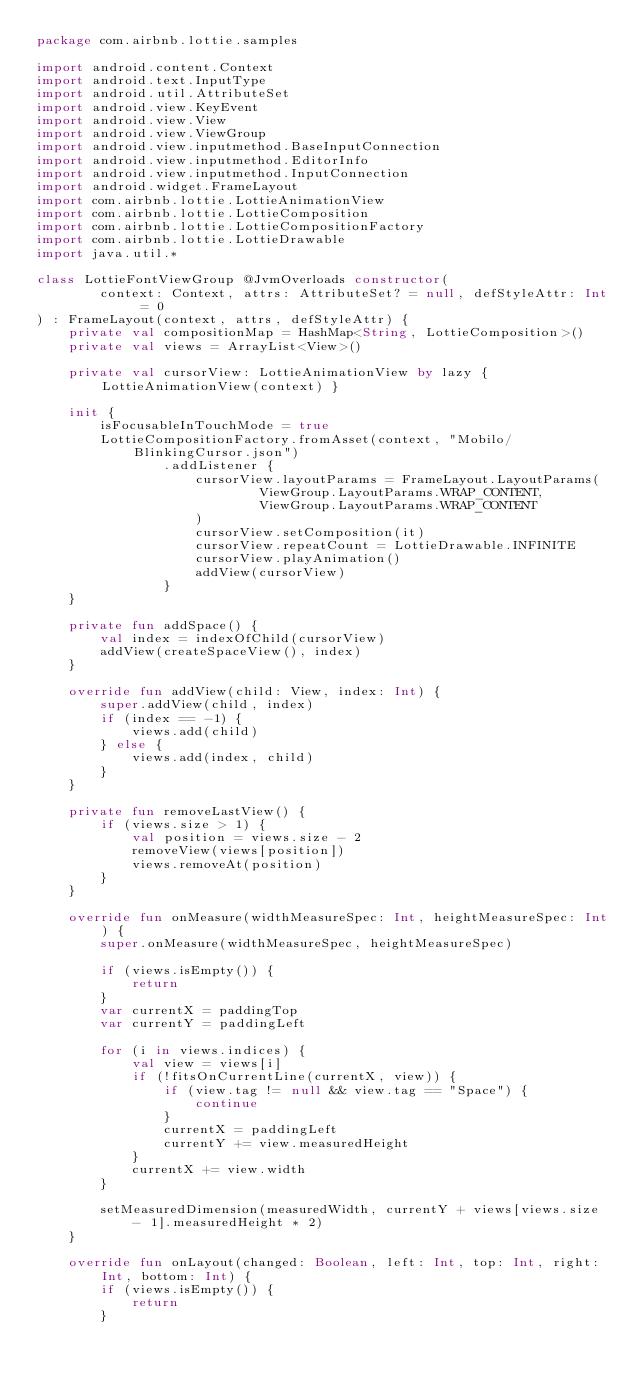<code> <loc_0><loc_0><loc_500><loc_500><_Kotlin_>package com.airbnb.lottie.samples

import android.content.Context
import android.text.InputType
import android.util.AttributeSet
import android.view.KeyEvent
import android.view.View
import android.view.ViewGroup
import android.view.inputmethod.BaseInputConnection
import android.view.inputmethod.EditorInfo
import android.view.inputmethod.InputConnection
import android.widget.FrameLayout
import com.airbnb.lottie.LottieAnimationView
import com.airbnb.lottie.LottieComposition
import com.airbnb.lottie.LottieCompositionFactory
import com.airbnb.lottie.LottieDrawable
import java.util.*

class LottieFontViewGroup @JvmOverloads constructor(
        context: Context, attrs: AttributeSet? = null, defStyleAttr: Int = 0
) : FrameLayout(context, attrs, defStyleAttr) {
    private val compositionMap = HashMap<String, LottieComposition>()
    private val views = ArrayList<View>()

    private val cursorView: LottieAnimationView by lazy { LottieAnimationView(context) }

    init {
        isFocusableInTouchMode = true
        LottieCompositionFactory.fromAsset(context, "Mobilo/BlinkingCursor.json")
                .addListener {
                    cursorView.layoutParams = FrameLayout.LayoutParams(
                            ViewGroup.LayoutParams.WRAP_CONTENT,
                            ViewGroup.LayoutParams.WRAP_CONTENT
                    )
                    cursorView.setComposition(it)
                    cursorView.repeatCount = LottieDrawable.INFINITE
                    cursorView.playAnimation()
                    addView(cursorView)
                }
    }

    private fun addSpace() {
        val index = indexOfChild(cursorView)
        addView(createSpaceView(), index)
    }

    override fun addView(child: View, index: Int) {
        super.addView(child, index)
        if (index == -1) {
            views.add(child)
        } else {
            views.add(index, child)
        }
    }

    private fun removeLastView() {
        if (views.size > 1) {
            val position = views.size - 2
            removeView(views[position])
            views.removeAt(position)
        }
    }

    override fun onMeasure(widthMeasureSpec: Int, heightMeasureSpec: Int) {
        super.onMeasure(widthMeasureSpec, heightMeasureSpec)

        if (views.isEmpty()) {
            return
        }
        var currentX = paddingTop
        var currentY = paddingLeft

        for (i in views.indices) {
            val view = views[i]
            if (!fitsOnCurrentLine(currentX, view)) {
                if (view.tag != null && view.tag == "Space") {
                    continue
                }
                currentX = paddingLeft
                currentY += view.measuredHeight
            }
            currentX += view.width
        }

        setMeasuredDimension(measuredWidth, currentY + views[views.size - 1].measuredHeight * 2)
    }

    override fun onLayout(changed: Boolean, left: Int, top: Int, right: Int, bottom: Int) {
        if (views.isEmpty()) {
            return
        }</code> 